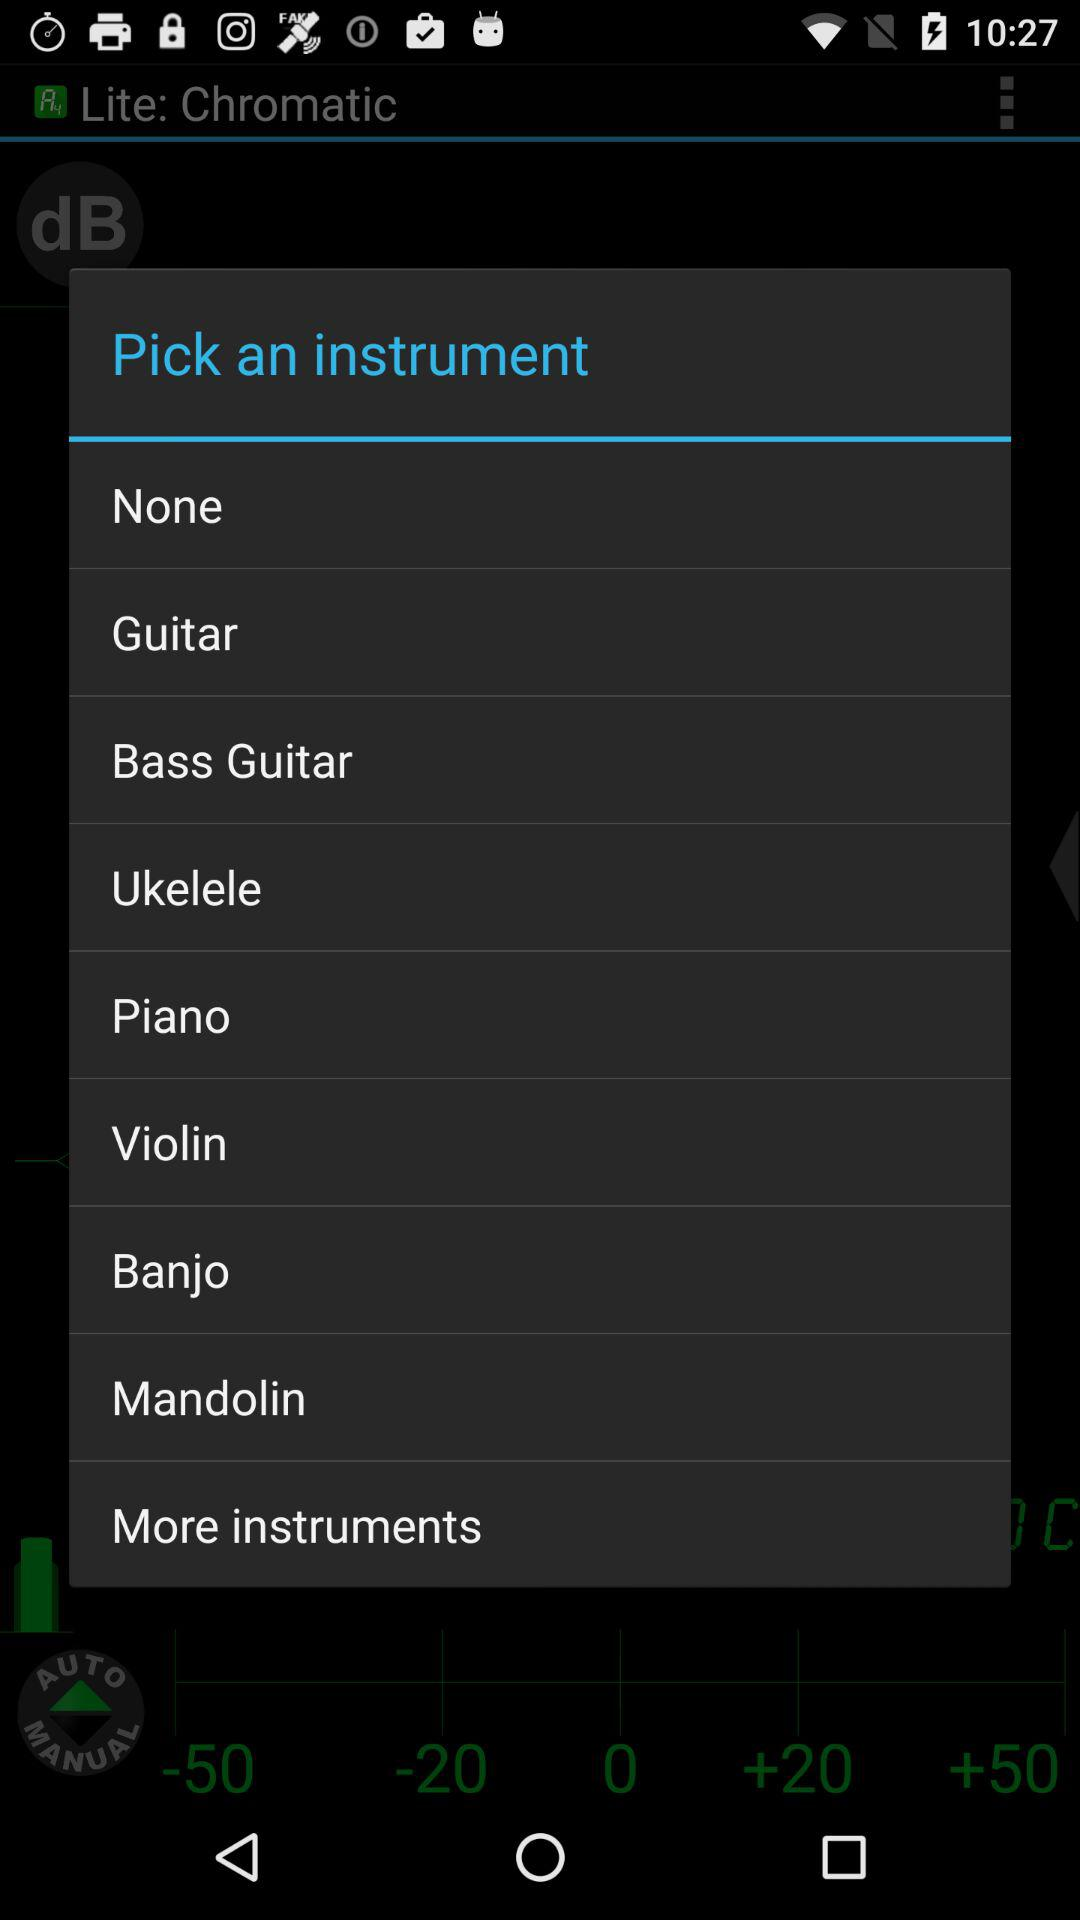What are the shown instruments? The shown instruments are guitar, bass guitar, ukelele, piano, violin, banjo and mandolin. 